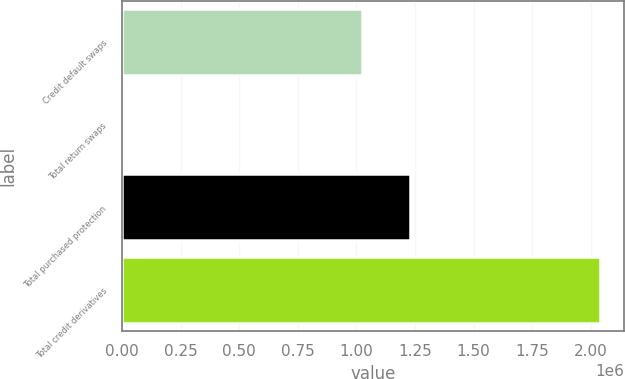Convert chart to OTSL. <chart><loc_0><loc_0><loc_500><loc_500><bar_chart><fcel>Credit default swaps<fcel>Total return swaps<fcel>Total purchased protection<fcel>Total credit derivatives<nl><fcel>1.02588e+06<fcel>6575<fcel>1.22909e+06<fcel>2.03869e+06<nl></chart> 